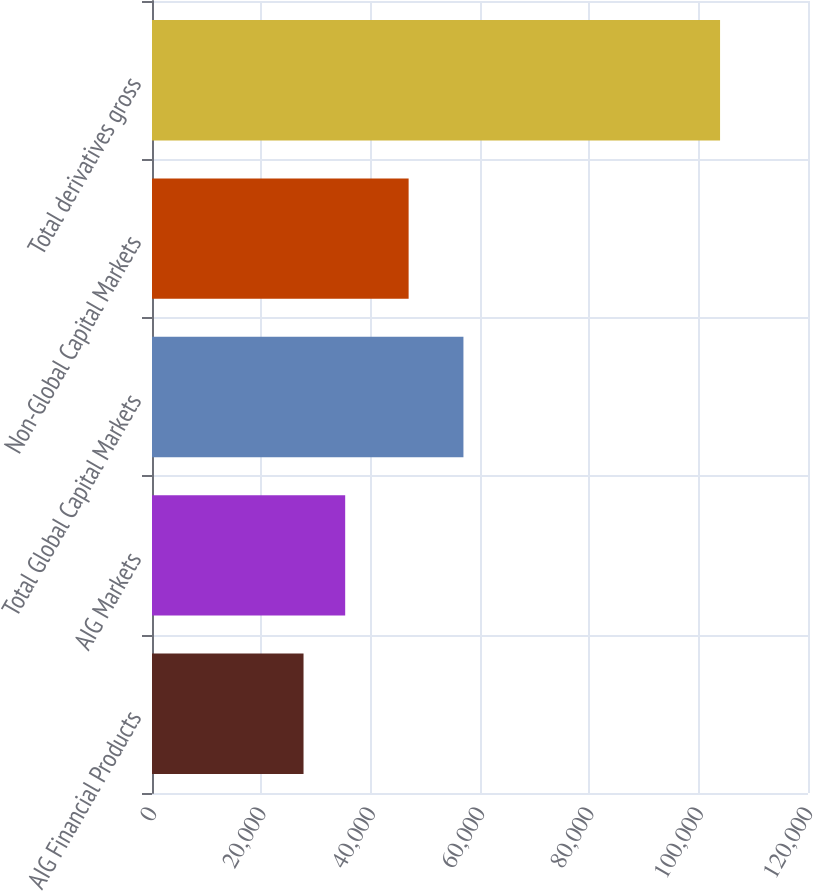Convert chart. <chart><loc_0><loc_0><loc_500><loc_500><bar_chart><fcel>AIG Financial Products<fcel>AIG Markets<fcel>Total Global Capital Markets<fcel>Non-Global Capital Markets<fcel>Total derivatives gross<nl><fcel>27719<fcel>35338.5<fcel>56970<fcel>46944<fcel>103914<nl></chart> 